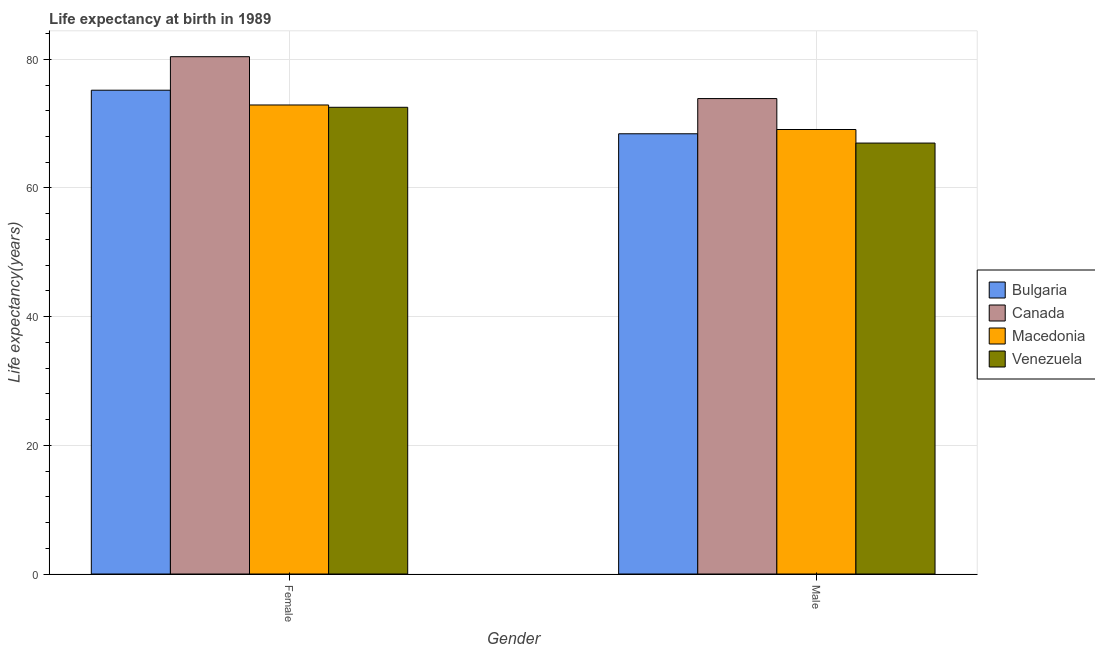How many different coloured bars are there?
Keep it short and to the point. 4. How many bars are there on the 2nd tick from the left?
Provide a short and direct response. 4. How many bars are there on the 1st tick from the right?
Provide a short and direct response. 4. What is the life expectancy(female) in Macedonia?
Ensure brevity in your answer.  72.89. Across all countries, what is the maximum life expectancy(male)?
Offer a terse response. 73.89. Across all countries, what is the minimum life expectancy(female)?
Keep it short and to the point. 72.54. In which country was the life expectancy(female) maximum?
Make the answer very short. Canada. In which country was the life expectancy(female) minimum?
Give a very brief answer. Venezuela. What is the total life expectancy(female) in the graph?
Your response must be concise. 301.02. What is the difference between the life expectancy(male) in Bulgaria and that in Venezuela?
Your answer should be very brief. 1.45. What is the difference between the life expectancy(female) in Canada and the life expectancy(male) in Macedonia?
Your answer should be compact. 11.32. What is the average life expectancy(female) per country?
Your response must be concise. 75.26. What is the difference between the life expectancy(male) and life expectancy(female) in Canada?
Your answer should be very brief. -6.51. What is the ratio of the life expectancy(male) in Venezuela to that in Canada?
Make the answer very short. 0.91. Is the life expectancy(female) in Canada less than that in Bulgaria?
Ensure brevity in your answer.  No. In how many countries, is the life expectancy(male) greater than the average life expectancy(male) taken over all countries?
Provide a succinct answer. 1. What does the 4th bar from the left in Male represents?
Make the answer very short. Venezuela. What does the 2nd bar from the right in Male represents?
Your answer should be compact. Macedonia. How many countries are there in the graph?
Ensure brevity in your answer.  4. Are the values on the major ticks of Y-axis written in scientific E-notation?
Your answer should be compact. No. Does the graph contain any zero values?
Offer a very short reply. No. Where does the legend appear in the graph?
Offer a terse response. Center right. How many legend labels are there?
Provide a short and direct response. 4. What is the title of the graph?
Ensure brevity in your answer.  Life expectancy at birth in 1989. Does "Barbados" appear as one of the legend labels in the graph?
Your answer should be compact. No. What is the label or title of the X-axis?
Make the answer very short. Gender. What is the label or title of the Y-axis?
Keep it short and to the point. Life expectancy(years). What is the Life expectancy(years) in Bulgaria in Female?
Offer a terse response. 75.19. What is the Life expectancy(years) of Canada in Female?
Ensure brevity in your answer.  80.4. What is the Life expectancy(years) of Macedonia in Female?
Offer a terse response. 72.89. What is the Life expectancy(years) of Venezuela in Female?
Offer a very short reply. 72.54. What is the Life expectancy(years) of Bulgaria in Male?
Provide a succinct answer. 68.42. What is the Life expectancy(years) in Canada in Male?
Make the answer very short. 73.89. What is the Life expectancy(years) of Macedonia in Male?
Provide a succinct answer. 69.08. What is the Life expectancy(years) of Venezuela in Male?
Make the answer very short. 66.97. Across all Gender, what is the maximum Life expectancy(years) of Bulgaria?
Offer a terse response. 75.19. Across all Gender, what is the maximum Life expectancy(years) of Canada?
Your response must be concise. 80.4. Across all Gender, what is the maximum Life expectancy(years) of Macedonia?
Ensure brevity in your answer.  72.89. Across all Gender, what is the maximum Life expectancy(years) of Venezuela?
Keep it short and to the point. 72.54. Across all Gender, what is the minimum Life expectancy(years) of Bulgaria?
Your answer should be compact. 68.42. Across all Gender, what is the minimum Life expectancy(years) of Canada?
Give a very brief answer. 73.89. Across all Gender, what is the minimum Life expectancy(years) in Macedonia?
Provide a short and direct response. 69.08. Across all Gender, what is the minimum Life expectancy(years) of Venezuela?
Give a very brief answer. 66.97. What is the total Life expectancy(years) of Bulgaria in the graph?
Make the answer very short. 143.61. What is the total Life expectancy(years) of Canada in the graph?
Keep it short and to the point. 154.29. What is the total Life expectancy(years) of Macedonia in the graph?
Provide a succinct answer. 141.98. What is the total Life expectancy(years) in Venezuela in the graph?
Make the answer very short. 139.51. What is the difference between the Life expectancy(years) in Bulgaria in Female and that in Male?
Ensure brevity in your answer.  6.77. What is the difference between the Life expectancy(years) of Canada in Female and that in Male?
Provide a short and direct response. 6.51. What is the difference between the Life expectancy(years) in Macedonia in Female and that in Male?
Your answer should be very brief. 3.81. What is the difference between the Life expectancy(years) of Venezuela in Female and that in Male?
Provide a short and direct response. 5.56. What is the difference between the Life expectancy(years) in Bulgaria in Female and the Life expectancy(years) in Canada in Male?
Give a very brief answer. 1.3. What is the difference between the Life expectancy(years) of Bulgaria in Female and the Life expectancy(years) of Macedonia in Male?
Provide a succinct answer. 6.11. What is the difference between the Life expectancy(years) of Bulgaria in Female and the Life expectancy(years) of Venezuela in Male?
Make the answer very short. 8.22. What is the difference between the Life expectancy(years) of Canada in Female and the Life expectancy(years) of Macedonia in Male?
Your response must be concise. 11.32. What is the difference between the Life expectancy(years) in Canada in Female and the Life expectancy(years) in Venezuela in Male?
Offer a terse response. 13.43. What is the difference between the Life expectancy(years) of Macedonia in Female and the Life expectancy(years) of Venezuela in Male?
Make the answer very short. 5.92. What is the average Life expectancy(years) in Bulgaria per Gender?
Make the answer very short. 71.81. What is the average Life expectancy(years) in Canada per Gender?
Keep it short and to the point. 77.14. What is the average Life expectancy(years) in Macedonia per Gender?
Make the answer very short. 70.99. What is the average Life expectancy(years) of Venezuela per Gender?
Your answer should be compact. 69.75. What is the difference between the Life expectancy(years) in Bulgaria and Life expectancy(years) in Canada in Female?
Offer a terse response. -5.21. What is the difference between the Life expectancy(years) in Bulgaria and Life expectancy(years) in Macedonia in Female?
Give a very brief answer. 2.29. What is the difference between the Life expectancy(years) in Bulgaria and Life expectancy(years) in Venezuela in Female?
Keep it short and to the point. 2.65. What is the difference between the Life expectancy(years) in Canada and Life expectancy(years) in Macedonia in Female?
Your answer should be very brief. 7.5. What is the difference between the Life expectancy(years) in Canada and Life expectancy(years) in Venezuela in Female?
Make the answer very short. 7.86. What is the difference between the Life expectancy(years) in Macedonia and Life expectancy(years) in Venezuela in Female?
Your answer should be compact. 0.36. What is the difference between the Life expectancy(years) in Bulgaria and Life expectancy(years) in Canada in Male?
Offer a very short reply. -5.47. What is the difference between the Life expectancy(years) of Bulgaria and Life expectancy(years) of Macedonia in Male?
Offer a terse response. -0.66. What is the difference between the Life expectancy(years) of Bulgaria and Life expectancy(years) of Venezuela in Male?
Offer a very short reply. 1.45. What is the difference between the Life expectancy(years) in Canada and Life expectancy(years) in Macedonia in Male?
Provide a short and direct response. 4.81. What is the difference between the Life expectancy(years) in Canada and Life expectancy(years) in Venezuela in Male?
Provide a succinct answer. 6.92. What is the difference between the Life expectancy(years) in Macedonia and Life expectancy(years) in Venezuela in Male?
Make the answer very short. 2.11. What is the ratio of the Life expectancy(years) in Bulgaria in Female to that in Male?
Provide a short and direct response. 1.1. What is the ratio of the Life expectancy(years) of Canada in Female to that in Male?
Your answer should be very brief. 1.09. What is the ratio of the Life expectancy(years) of Macedonia in Female to that in Male?
Your response must be concise. 1.06. What is the ratio of the Life expectancy(years) in Venezuela in Female to that in Male?
Make the answer very short. 1.08. What is the difference between the highest and the second highest Life expectancy(years) in Bulgaria?
Your answer should be compact. 6.77. What is the difference between the highest and the second highest Life expectancy(years) of Canada?
Make the answer very short. 6.51. What is the difference between the highest and the second highest Life expectancy(years) in Macedonia?
Provide a succinct answer. 3.81. What is the difference between the highest and the second highest Life expectancy(years) of Venezuela?
Provide a succinct answer. 5.56. What is the difference between the highest and the lowest Life expectancy(years) in Bulgaria?
Your answer should be compact. 6.77. What is the difference between the highest and the lowest Life expectancy(years) in Canada?
Ensure brevity in your answer.  6.51. What is the difference between the highest and the lowest Life expectancy(years) in Macedonia?
Make the answer very short. 3.81. What is the difference between the highest and the lowest Life expectancy(years) of Venezuela?
Your response must be concise. 5.56. 